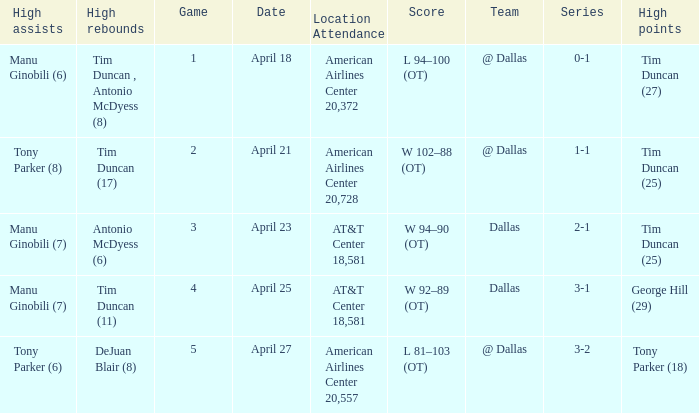When 0-1 is the series who has the highest amount of assists? Manu Ginobili (6). 